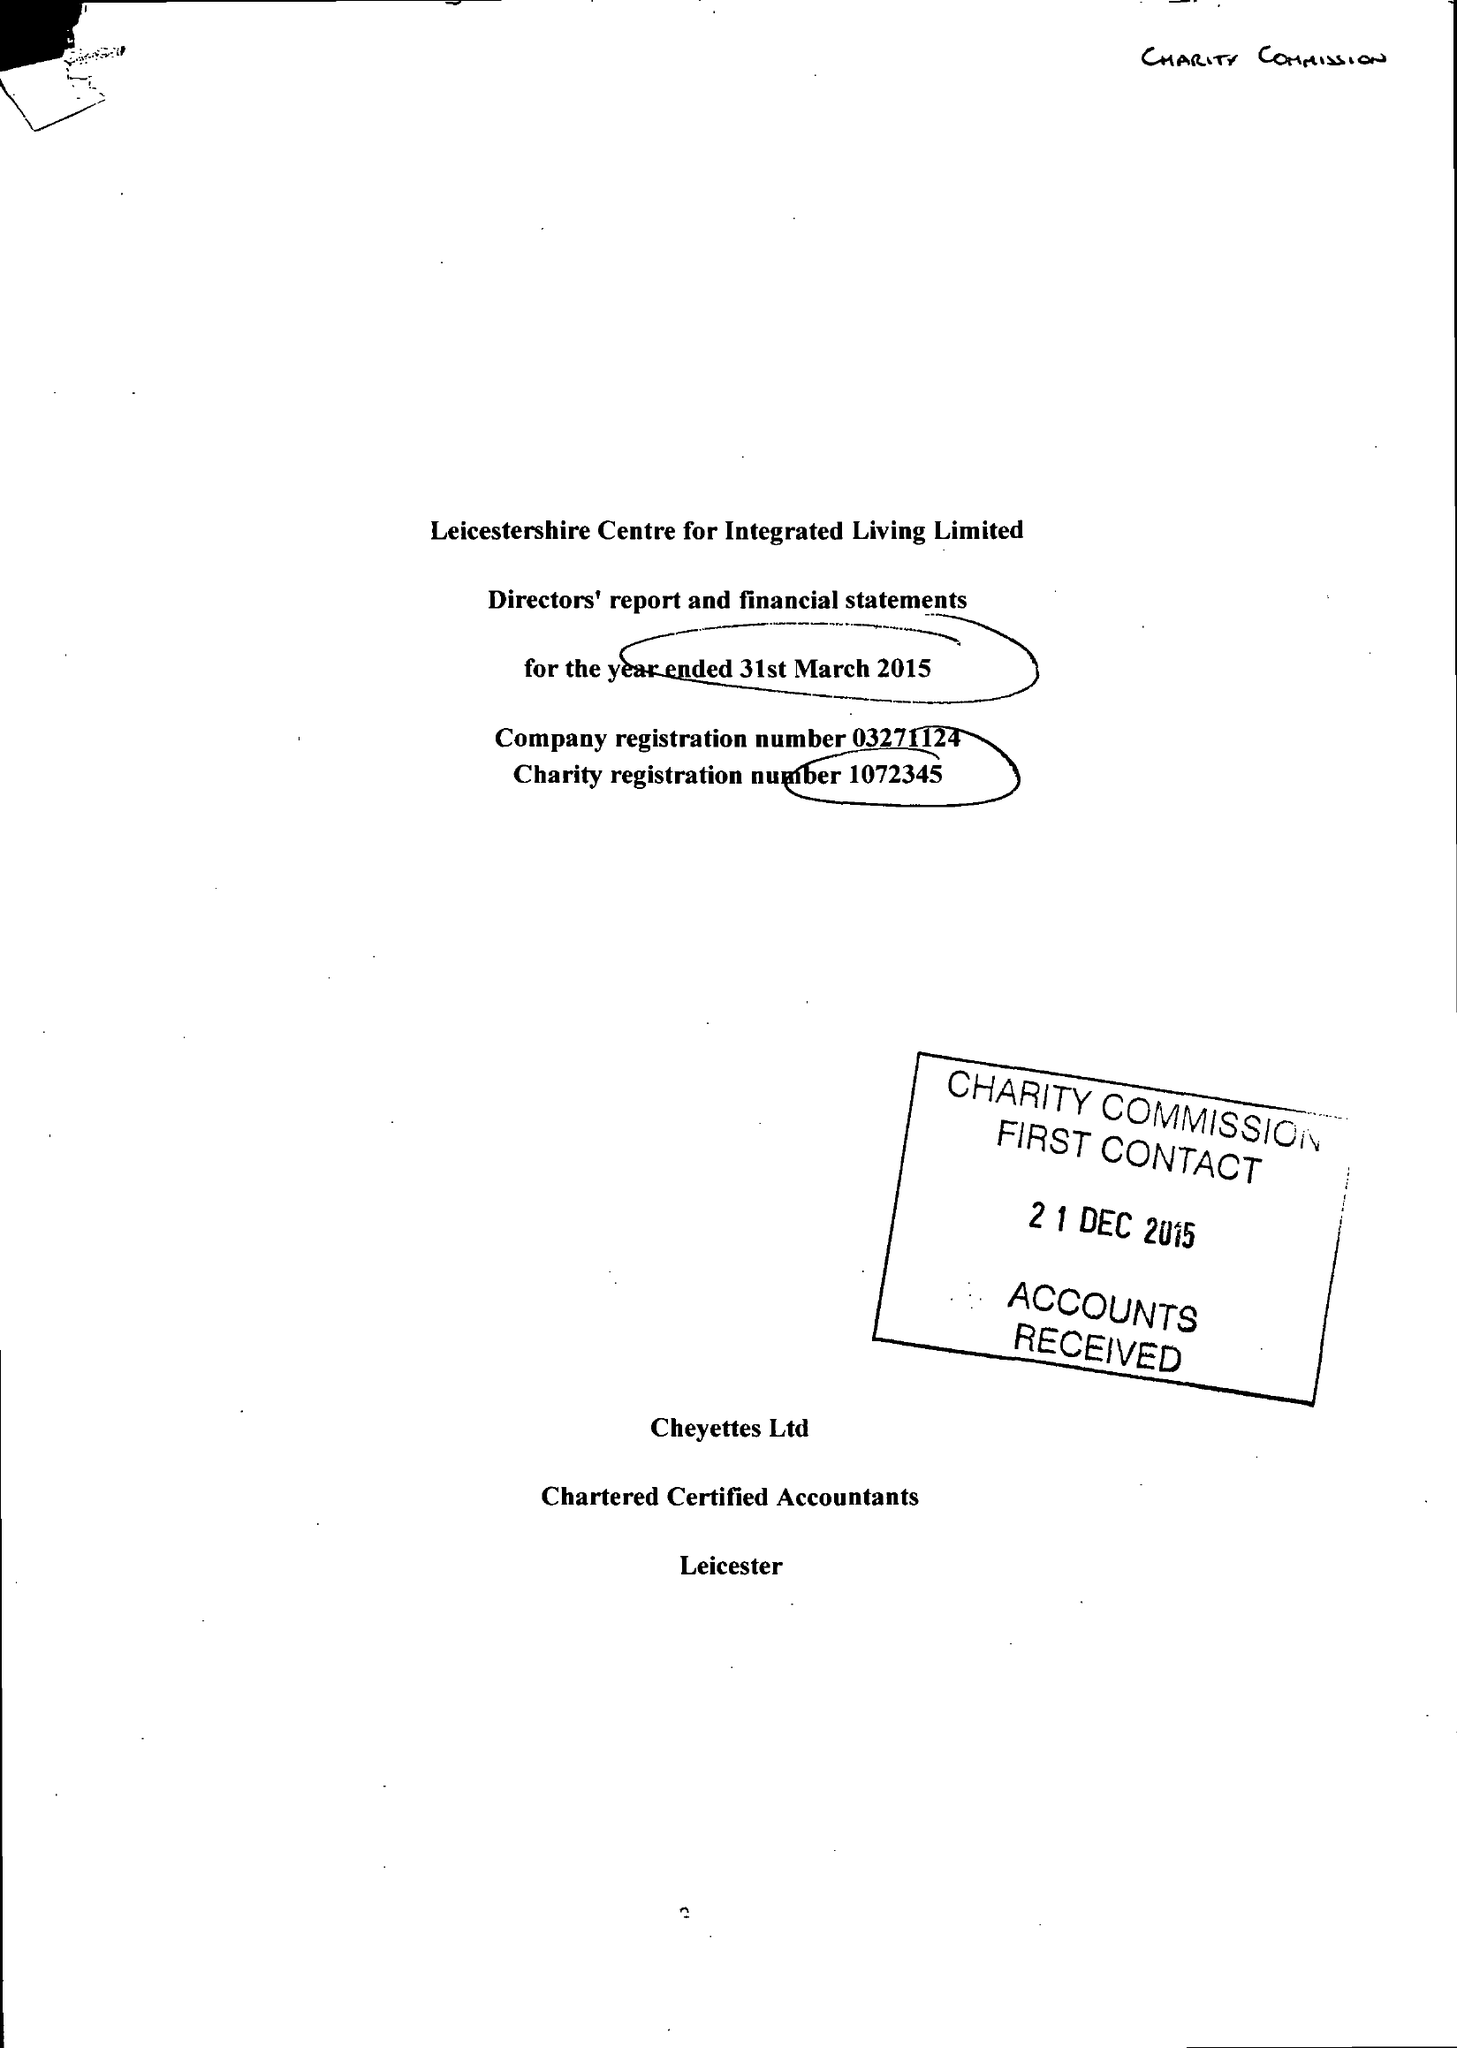What is the value for the spending_annually_in_british_pounds?
Answer the question using a single word or phrase. 88352.00 